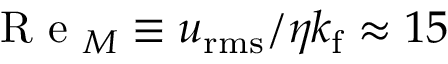<formula> <loc_0><loc_0><loc_500><loc_500>R e _ { M } \equiv u _ { r m s } / \eta k _ { f } \approx 1 5</formula> 